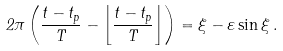Convert formula to latex. <formula><loc_0><loc_0><loc_500><loc_500>2 \pi \left ( \frac { t - t _ { p } } { T } - \left \lfloor \frac { t - t _ { p } } { T } \right \rfloor \right ) = \xi - \varepsilon \sin \xi \, .</formula> 